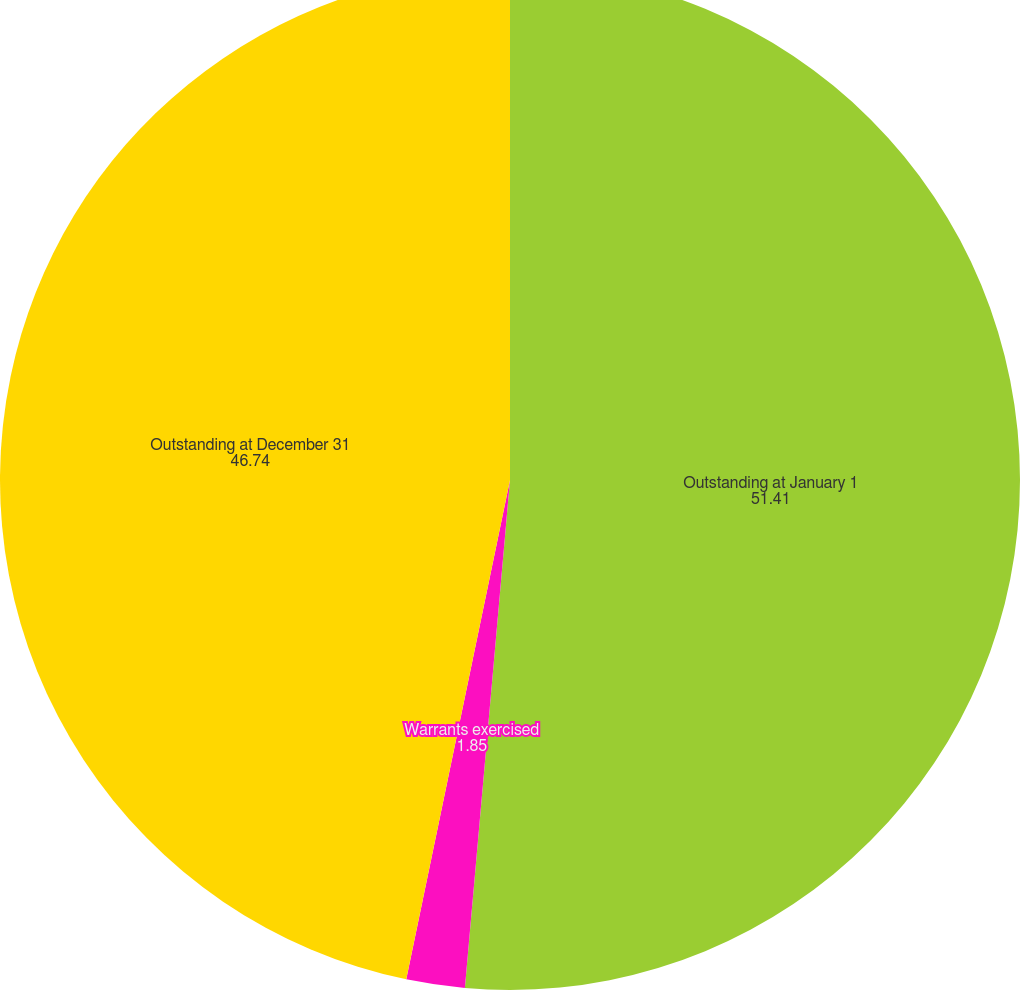Convert chart to OTSL. <chart><loc_0><loc_0><loc_500><loc_500><pie_chart><fcel>Outstanding at January 1<fcel>Warrants exercised<fcel>Outstanding at December 31<nl><fcel>51.41%<fcel>1.85%<fcel>46.74%<nl></chart> 